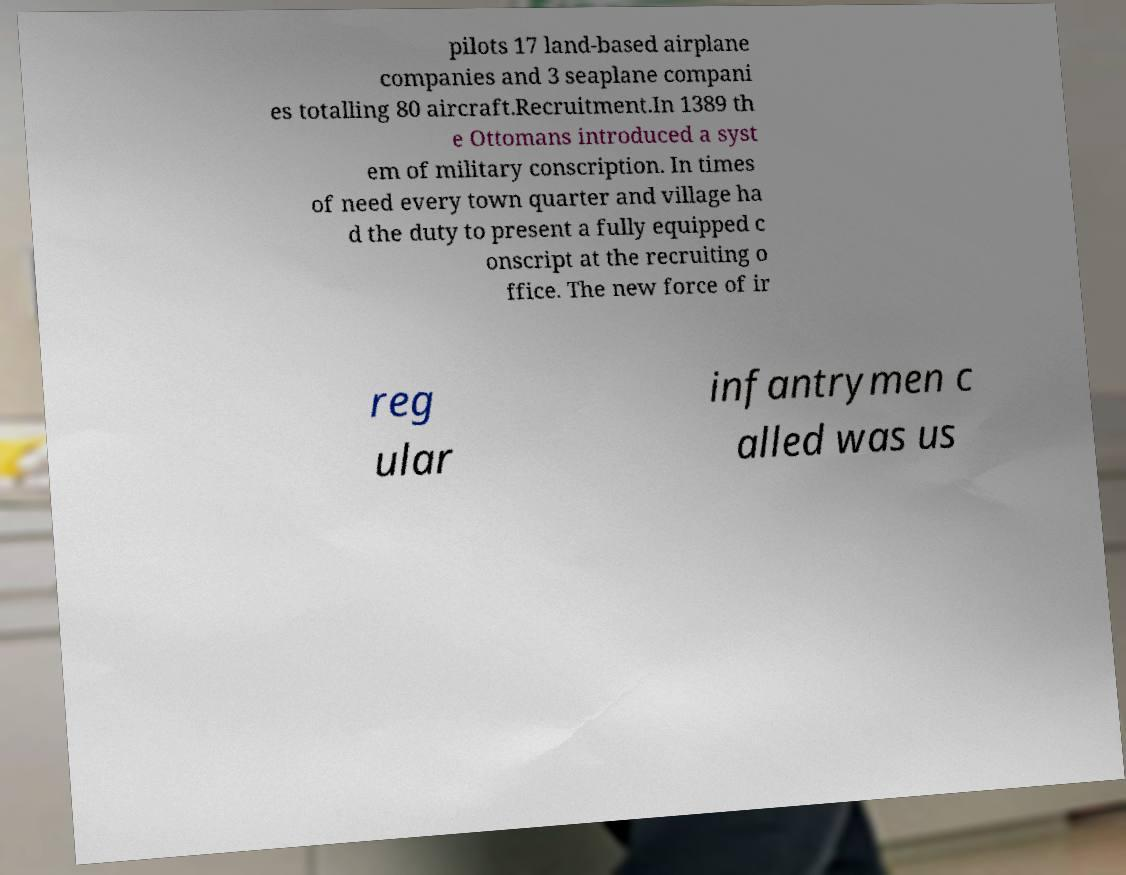What messages or text are displayed in this image? I need them in a readable, typed format. pilots 17 land-based airplane companies and 3 seaplane compani es totalling 80 aircraft.Recruitment.In 1389 th e Ottomans introduced a syst em of military conscription. In times of need every town quarter and village ha d the duty to present a fully equipped c onscript at the recruiting o ffice. The new force of ir reg ular infantrymen c alled was us 